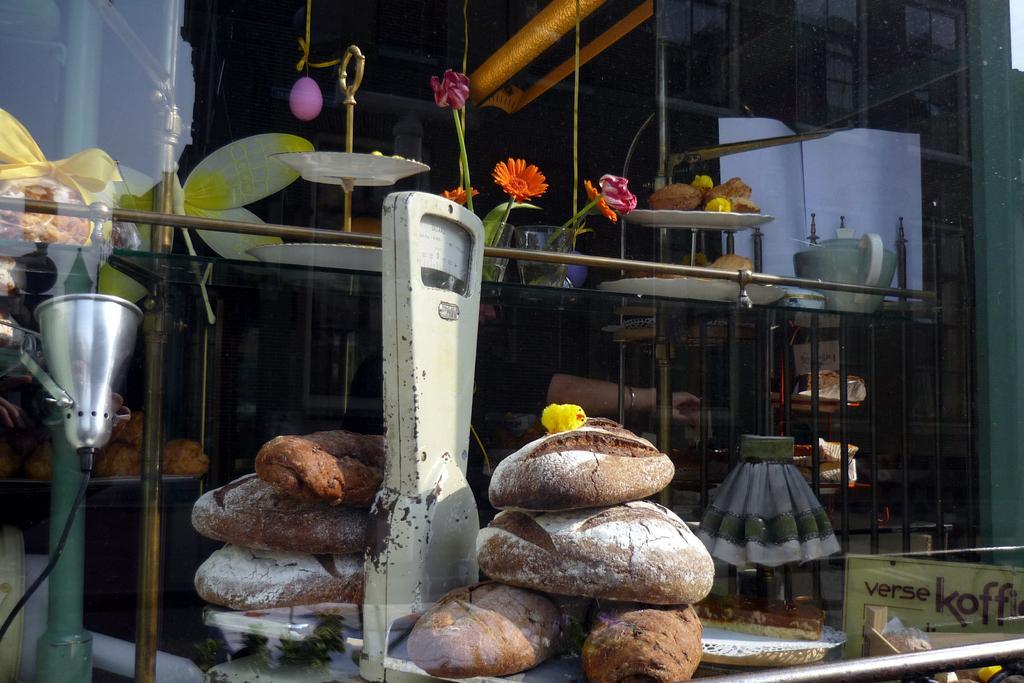Describe this image in one or two sentences. This is the picture of a weighing machine on which there are some breads and to the side there is a fencing, table on which there are some things placed and also we can see some plants and some other things. 